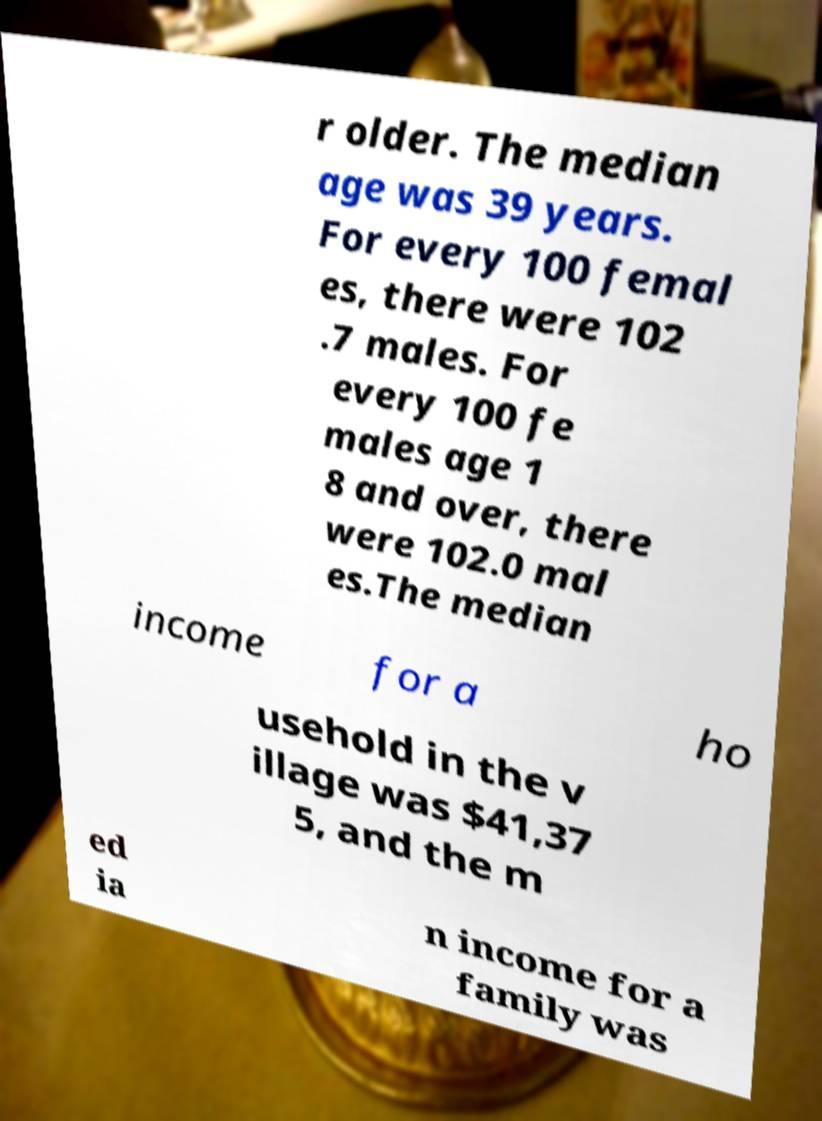I need the written content from this picture converted into text. Can you do that? r older. The median age was 39 years. For every 100 femal es, there were 102 .7 males. For every 100 fe males age 1 8 and over, there were 102.0 mal es.The median income for a ho usehold in the v illage was $41,37 5, and the m ed ia n income for a family was 